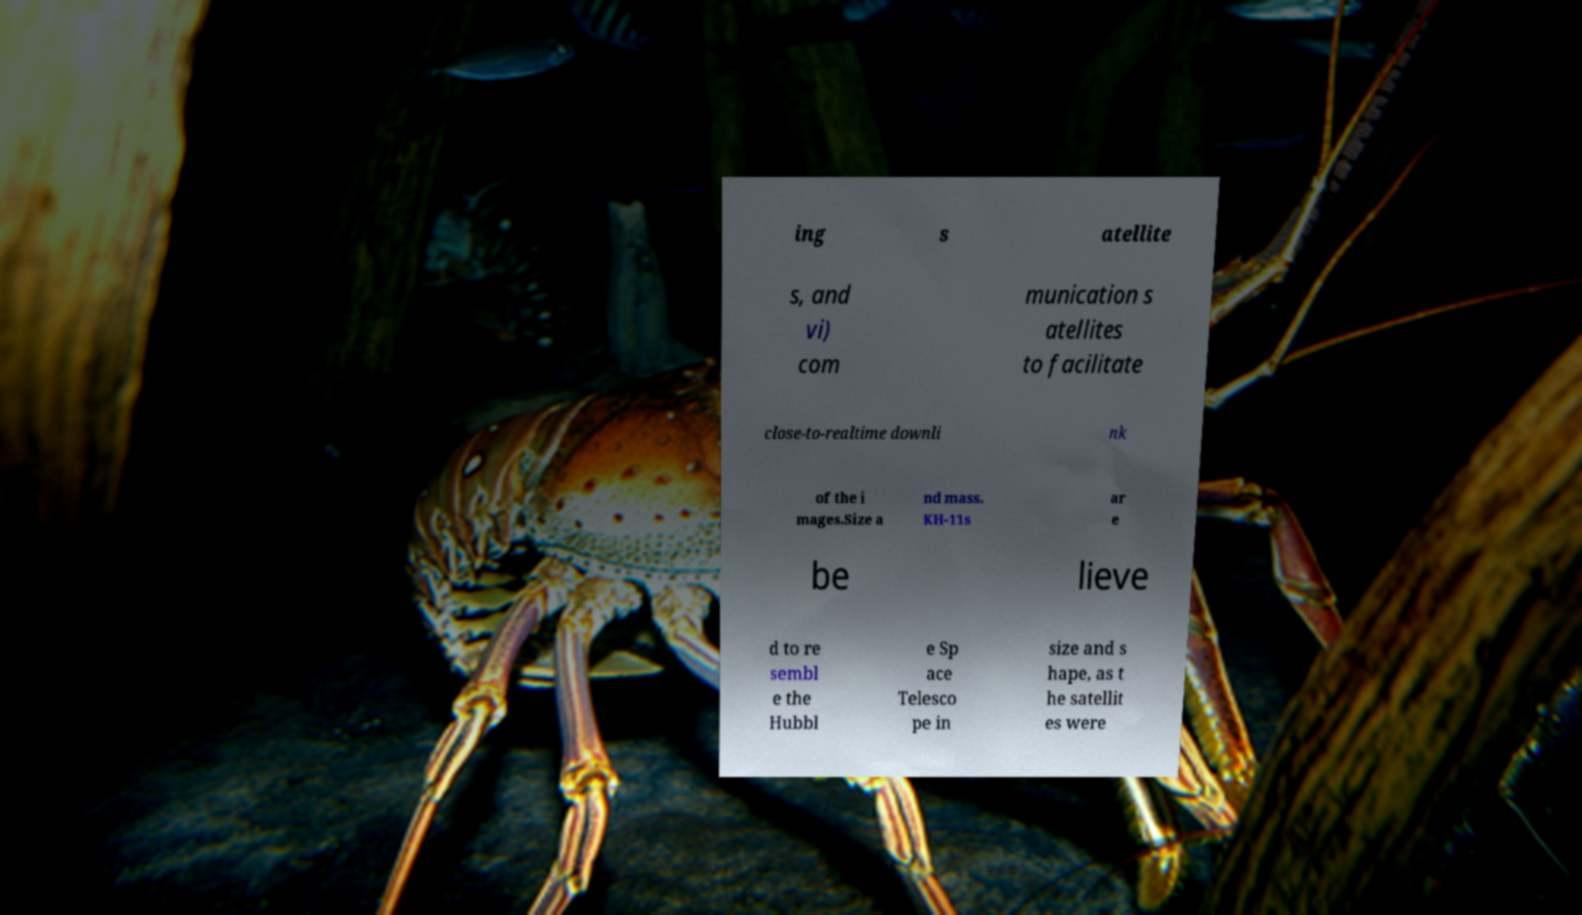What messages or text are displayed in this image? I need them in a readable, typed format. ing s atellite s, and vi) com munication s atellites to facilitate close-to-realtime downli nk of the i mages.Size a nd mass. KH-11s ar e be lieve d to re sembl e the Hubbl e Sp ace Telesco pe in size and s hape, as t he satellit es were 